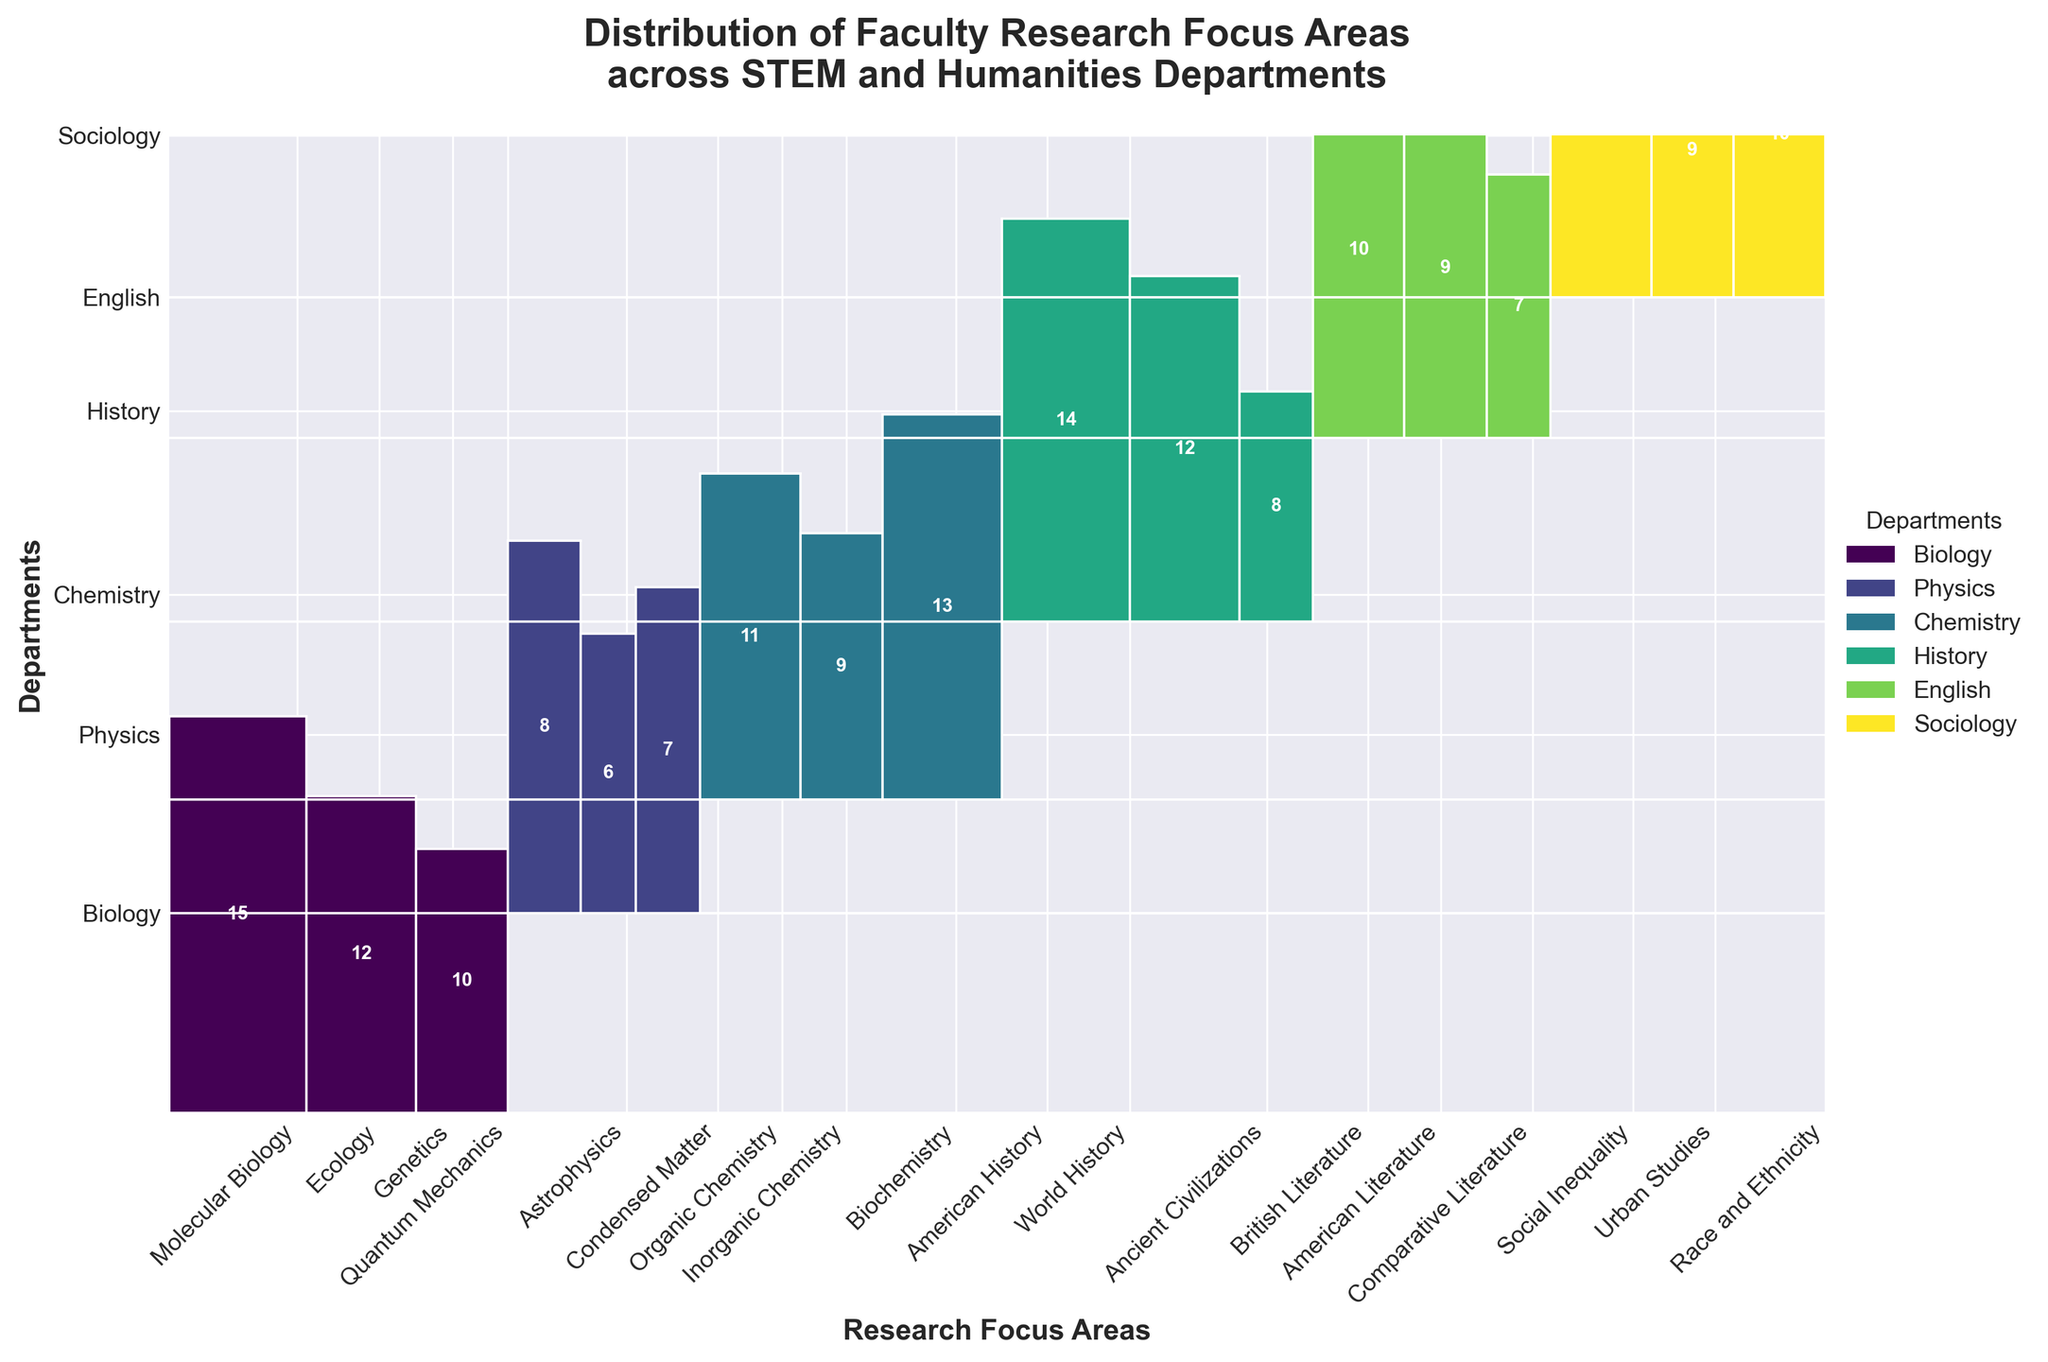What is the title of the figure? The title is displayed at the top of the figure in larger, bold font. It provides a brief description of what the figure represents.
Answer: Distribution of Faculty Research Focus Areas across STEM and Humanities Departments Which department has the greatest number of faculty members focusing on Molecular Biology? By looking at the color blocks in the Molecular Biology section, we can see that Biology has the only sections colored, indicating it has faculty members in Molecular Biology.
Answer: Biology What's the sum of faculty members in American History and British Literature? From the height of the respective sections for American History and British Literature in the History and English departments, we can see that they add up to 14 and 10 respectively. Sum these values: 14 + 10 = 24
Answer: 24 Which department has a greater number of faculty members in organic chemistry: Biology or Chemistry? In the mosaic sections dedicated to Organic Chemistry, we compare the heights for Biology and Chemistry. Biology has no faculty in this focus area as indicated by no color block, while Chemistry has a visible block representing 11 faculty members.
Answer: Chemistry What's the proportion of Quantum Mechanics faculty members within the Physics Department? To calculate the proportion, we take the number of Physics faculty members focusing on Quantum Mechanics (8) and divide by the total number of Physics faculty members (8+6+7=21). The proportion is thus 8/21.
Answer: 8/21 Which department has the smallest representation in the figure, and what could this indicate? By observing the overall size of each department's colored sections in the mosaic plot, we can see that the English department has the fewest total faculty as indicated by the smaller sections.
Answer: English In which research focus area does the Sociology department have most of its faculty? Looking at the mosaic plot, we assess the highest section within the Sociology department color blocks. The tallest bar under Sociology is for Social Inequality.
Answer: Social Inequality Is there any overlap between the research focus areas of Biology and History? The mosaic plot shows distinct color blocks for different departments and their research focus areas i.e., Biological sciences and History have no shared research focus disciplines.
Answer: No Compare the faculty counts of Ecology in Biology to World History in History. Which focus area has more? In the mosaic sections dedicated to Ecology in Biology and World History in History, we compare the representative block heights. Ecology has 12 faculty while World History has 12 as well, indicating they are equal.
Answer: Both are equal What's the general trend of faculty distribution among STEM and humanities departments? Visually, the mosaic plot indicates larger blocks for STEM-related research areas in comparison to the Humanities departments which could indicate a higher overall number of faculty in STEM.
Answer: More faculty in STEM 